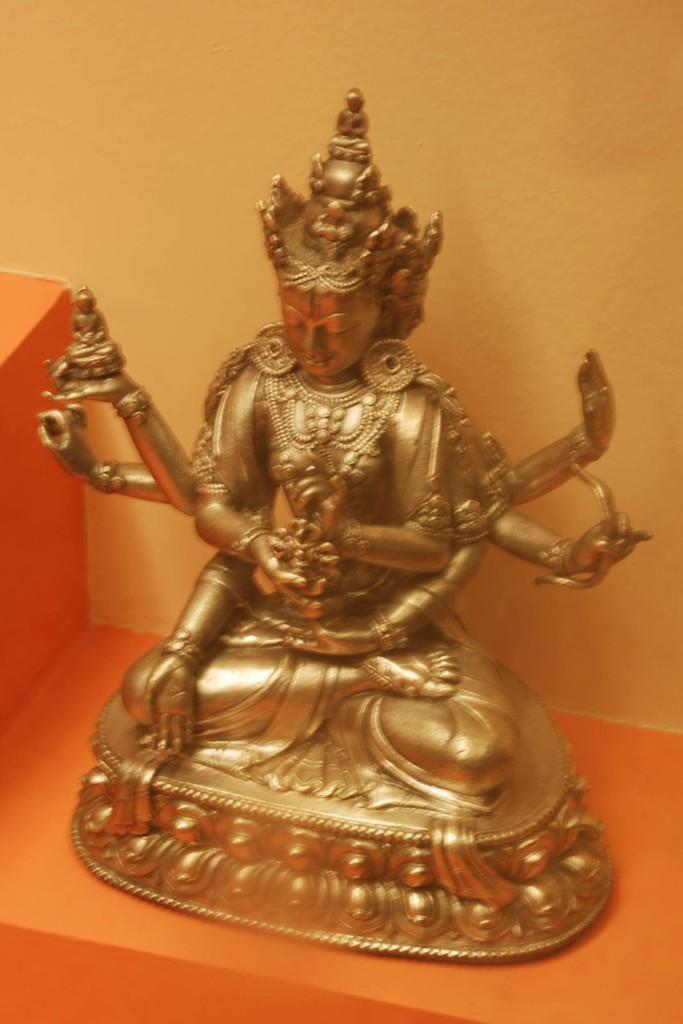What type of object is the main subject of the image? There is a golden color mini sculpture in the image. What is the color of the surface on which the sculpture is placed? There is an orange color surface in the image. What can be seen in the background of the image? There is a yellow color wall in the background of the image. Can you see a cat sleeping on the orange surface in the image? There is no cat present in the image; it only features a golden color mini sculpture on an orange surface with a yellow color wall in the background. 